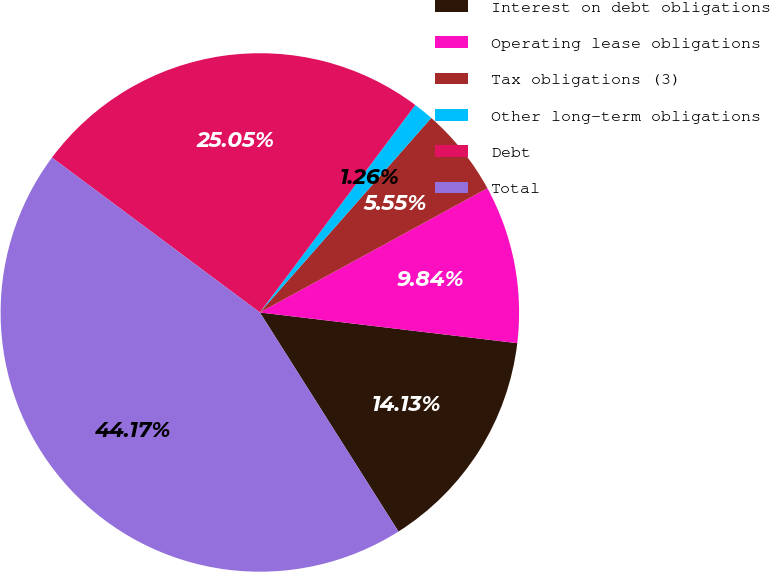Convert chart to OTSL. <chart><loc_0><loc_0><loc_500><loc_500><pie_chart><fcel>Interest on debt obligations<fcel>Operating lease obligations<fcel>Tax obligations (3)<fcel>Other long-term obligations<fcel>Debt<fcel>Total<nl><fcel>14.13%<fcel>9.84%<fcel>5.55%<fcel>1.26%<fcel>25.04%<fcel>44.16%<nl></chart> 